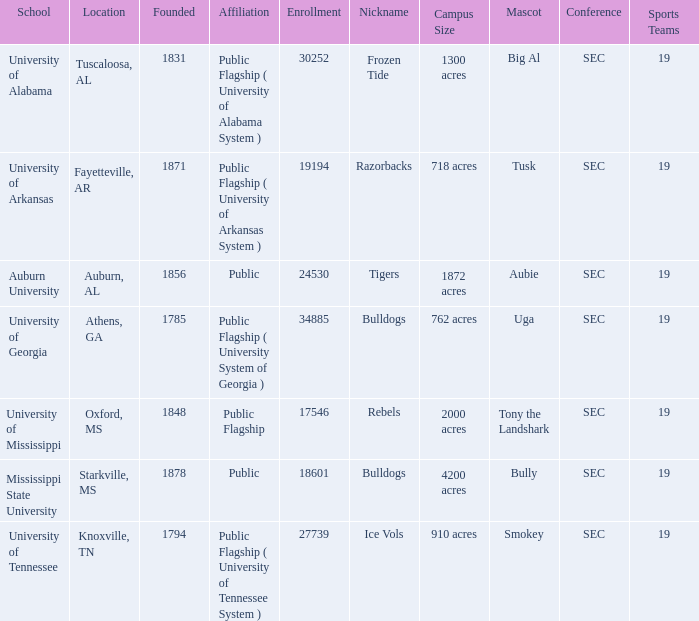Can you give me this table as a dict? {'header': ['School', 'Location', 'Founded', 'Affiliation', 'Enrollment', 'Nickname', 'Campus Size', 'Mascot', 'Conference', 'Sports Teams'], 'rows': [['University of Alabama', 'Tuscaloosa, AL', '1831', 'Public Flagship ( University of Alabama System )', '30252', 'Frozen Tide', '1300 acres', 'Big Al', 'SEC', '19'], ['University of Arkansas', 'Fayetteville, AR', '1871', 'Public Flagship ( University of Arkansas System )', '19194', 'Razorbacks', '718 acres', 'Tusk', 'SEC', '19'], ['Auburn University', 'Auburn, AL', '1856', 'Public', '24530', 'Tigers', '1872 acres', 'Aubie', 'SEC', '19'], ['University of Georgia', 'Athens, GA', '1785', 'Public Flagship ( University System of Georgia )', '34885', 'Bulldogs', '762 acres', 'Uga', 'SEC', '19'], ['University of Mississippi', 'Oxford, MS', '1848', 'Public Flagship', '17546', 'Rebels', '2000 acres', 'Tony the Landshark', 'SEC', '19'], ['Mississippi State University', 'Starkville, MS', '1878', 'Public', '18601', 'Bulldogs', '4200 acres', 'Bully', 'SEC', '19'], ['University of Tennessee', 'Knoxville, TN', '1794', 'Public Flagship ( University of Tennessee System )', '27739', 'Ice Vols', '910 acres', 'Smokey', 'SEC', '19']]} What is the nickname of the University of Alabama? Frozen Tide. 